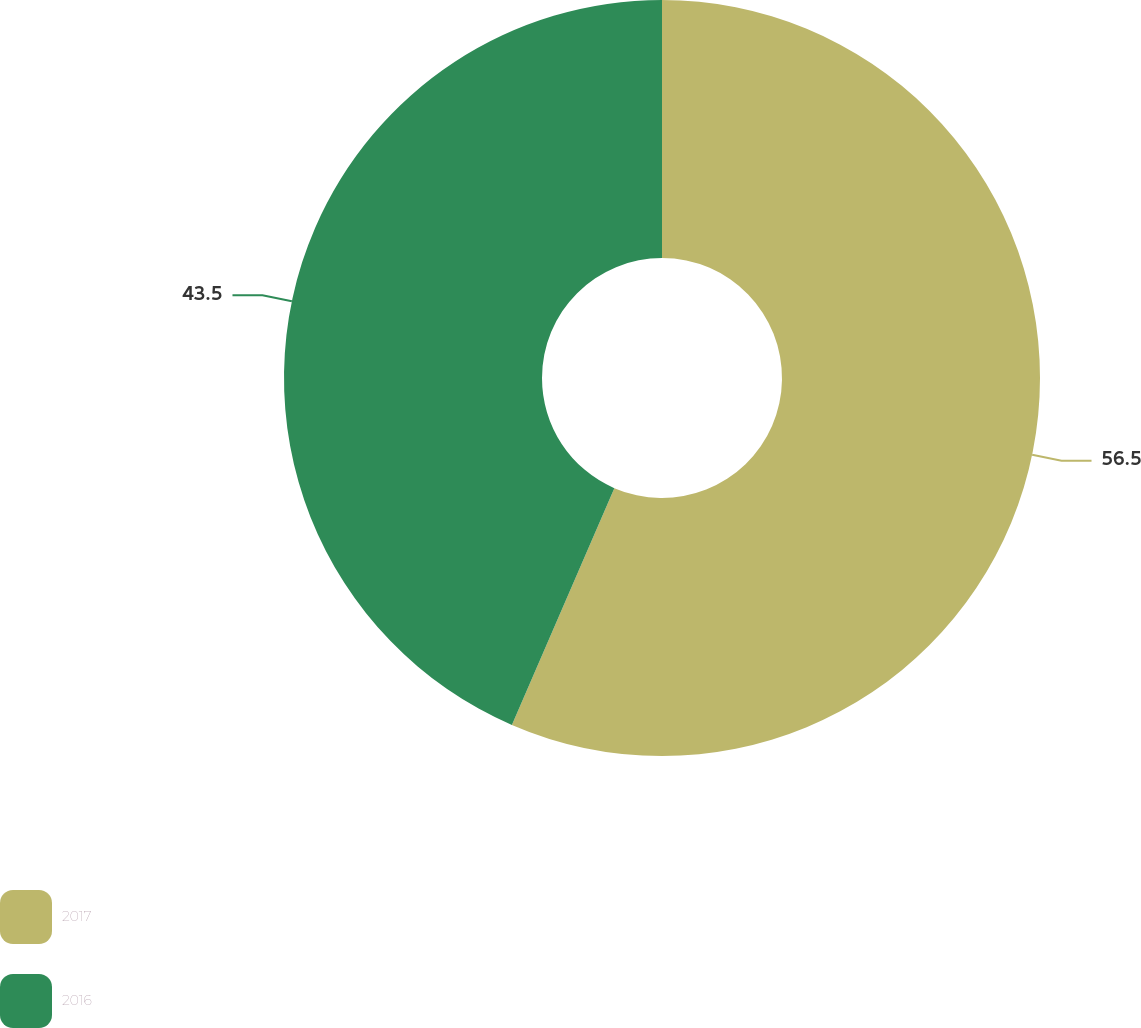Convert chart. <chart><loc_0><loc_0><loc_500><loc_500><pie_chart><fcel>2017<fcel>2016<nl><fcel>56.5%<fcel>43.5%<nl></chart> 